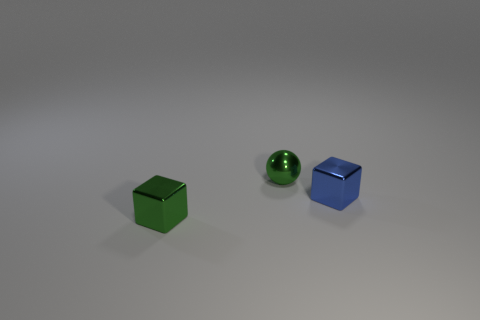How big is the shiny cube on the right side of the small green metal block?
Make the answer very short. Small. Are there any other things that have the same color as the metal ball?
Provide a short and direct response. Yes. Are there any tiny green cubes to the left of the small green block that is on the left side of the tiny object behind the blue cube?
Make the answer very short. No. There is a small block that is on the right side of the tiny sphere; is its color the same as the ball?
Give a very brief answer. No. What number of cylinders are blue things or green objects?
Provide a succinct answer. 0. There is a small object that is on the left side of the tiny green metal thing behind the blue block; what is its shape?
Make the answer very short. Cube. What size is the thing that is in front of the tiny block on the right side of the small shiny block that is in front of the blue block?
Your response must be concise. Small. Does the green sphere have the same size as the blue metallic thing?
Offer a very short reply. Yes. What number of things are big gray objects or small objects?
Ensure brevity in your answer.  3. There is a green thing to the right of the green shiny object in front of the blue metal thing; what is its size?
Your answer should be compact. Small. 